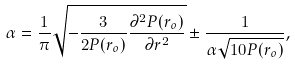Convert formula to latex. <formula><loc_0><loc_0><loc_500><loc_500>\alpha = \frac { 1 } { \pi } \sqrt { - \frac { 3 } { 2 P ( r _ { o } ) } \frac { \partial ^ { 2 } P ( r _ { o } ) } { \partial r ^ { 2 } } } \pm \frac { 1 } { \alpha \sqrt { 1 0 P ( r _ { o } ) } } ,</formula> 